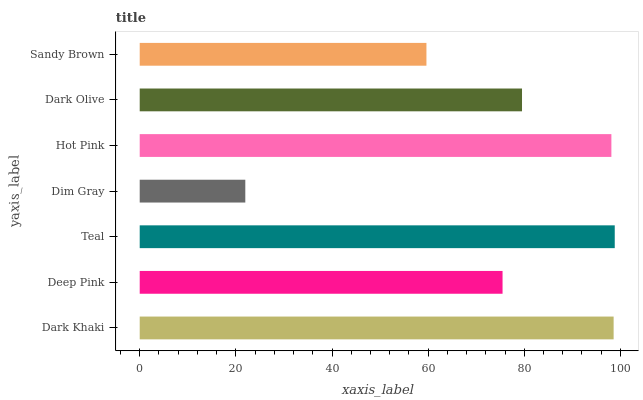Is Dim Gray the minimum?
Answer yes or no. Yes. Is Teal the maximum?
Answer yes or no. Yes. Is Deep Pink the minimum?
Answer yes or no. No. Is Deep Pink the maximum?
Answer yes or no. No. Is Dark Khaki greater than Deep Pink?
Answer yes or no. Yes. Is Deep Pink less than Dark Khaki?
Answer yes or no. Yes. Is Deep Pink greater than Dark Khaki?
Answer yes or no. No. Is Dark Khaki less than Deep Pink?
Answer yes or no. No. Is Dark Olive the high median?
Answer yes or no. Yes. Is Dark Olive the low median?
Answer yes or no. Yes. Is Dim Gray the high median?
Answer yes or no. No. Is Sandy Brown the low median?
Answer yes or no. No. 